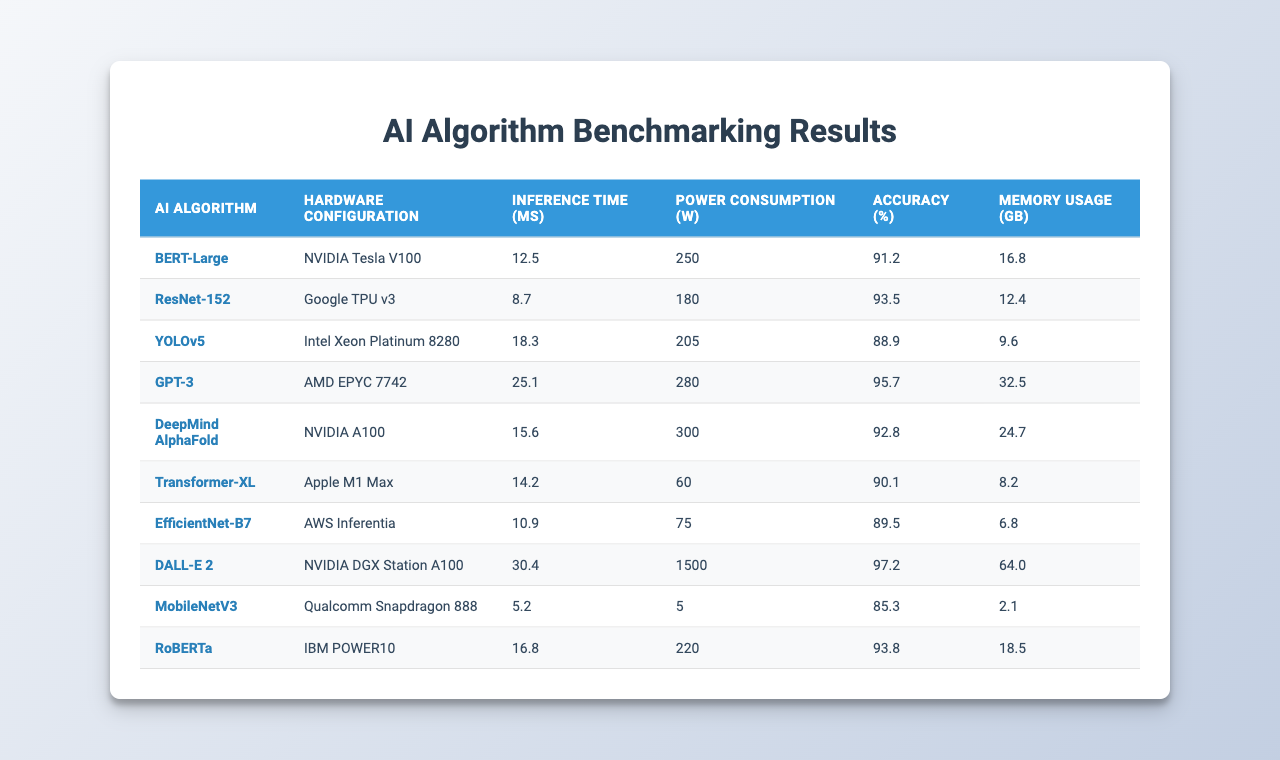What is the inference time of GPT-3? The inference time for GPT-3 is displayed in the table, specifically under the column "Inference Time (ms)," which shows 25.1 milliseconds.
Answer: 25.1 ms Which algorithm has the highest accuracy? The accuracy values for each algorithm can be found in the "Accuracy (%)" column. By comparing all values, DALL-E 2 has the highest accuracy at 97.2%.
Answer: 97.2% What is the power consumption of the NVIDIA A100 hardware configuration? The power consumption for the NVIDIA A100 is indicated in the "Power Consumption (W)" column, showing a value of 300 watts.
Answer: 300 W Which AI algorithm uses the least memory? By checking the "Memory Usage (GB)" column, MobileNetV3, with a value of 2.1 GB, uses the least memory compared to the other algorithms listed.
Answer: 2.1 GB Is the inference time of EfficientNet-B7 lower than 15 ms? EfficientNet-B7’s inference time is 10.9 ms, which is lower than 15 ms, confirming the statement is true.
Answer: Yes Calculate the average power consumption of NVIDIA Tesla V100, Google TPU v3, and AMD EPYC 7742. The power consumption for these configurations is 250 W, 180 W, and 280 W respectively. Summing these gives 250 + 180 + 280 = 710 W. The average is then 710 W / 3 = 236.67 W.
Answer: 236.67 W Which algorithm has the highest power consumption and what is that value? By examining the "Power Consumption (W)" column, DALL-E 2 has the highest value at 1500 watts.
Answer: 1500 W Is the accuracy of DeepMind AlphaFold greater than 90%? DeepMind AlphaFold's accuracy is at 92.8%, which is indeed greater than 90%, so the statement holds true.
Answer: Yes What is the difference in inference time between YOLOv5 and MobileNetV3? YOLOv5 takes 18.3 ms, and MobileNetV3 takes 5.2 ms. The difference is calculated as 18.3 - 5.2 = 13.1 ms.
Answer: 13.1 ms If we sum the accuracies of all algorithms, what is the total? The accuracies are: 91.2, 93.5, 88.9, 95.7, 92.8, 90.1, 89.5, 97.2, 85.3, and 93.8. Summing these gives a total of 920.8%.
Answer: 920.8% 